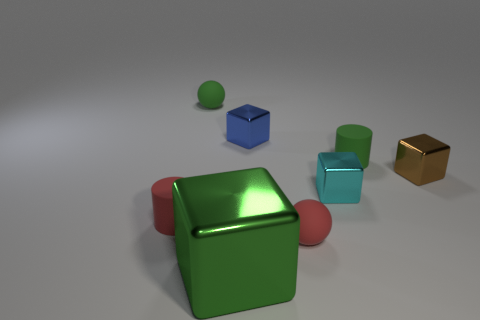Subtract all green cubes. How many cubes are left? 3 Subtract all red cylinders. How many cylinders are left? 1 Subtract all cylinders. How many objects are left? 6 Subtract all cyan metal objects. Subtract all big red matte objects. How many objects are left? 7 Add 3 green spheres. How many green spheres are left? 4 Add 2 small yellow blocks. How many small yellow blocks exist? 2 Add 1 big green balls. How many objects exist? 9 Subtract 0 brown balls. How many objects are left? 8 Subtract 2 spheres. How many spheres are left? 0 Subtract all brown cubes. Subtract all yellow cylinders. How many cubes are left? 3 